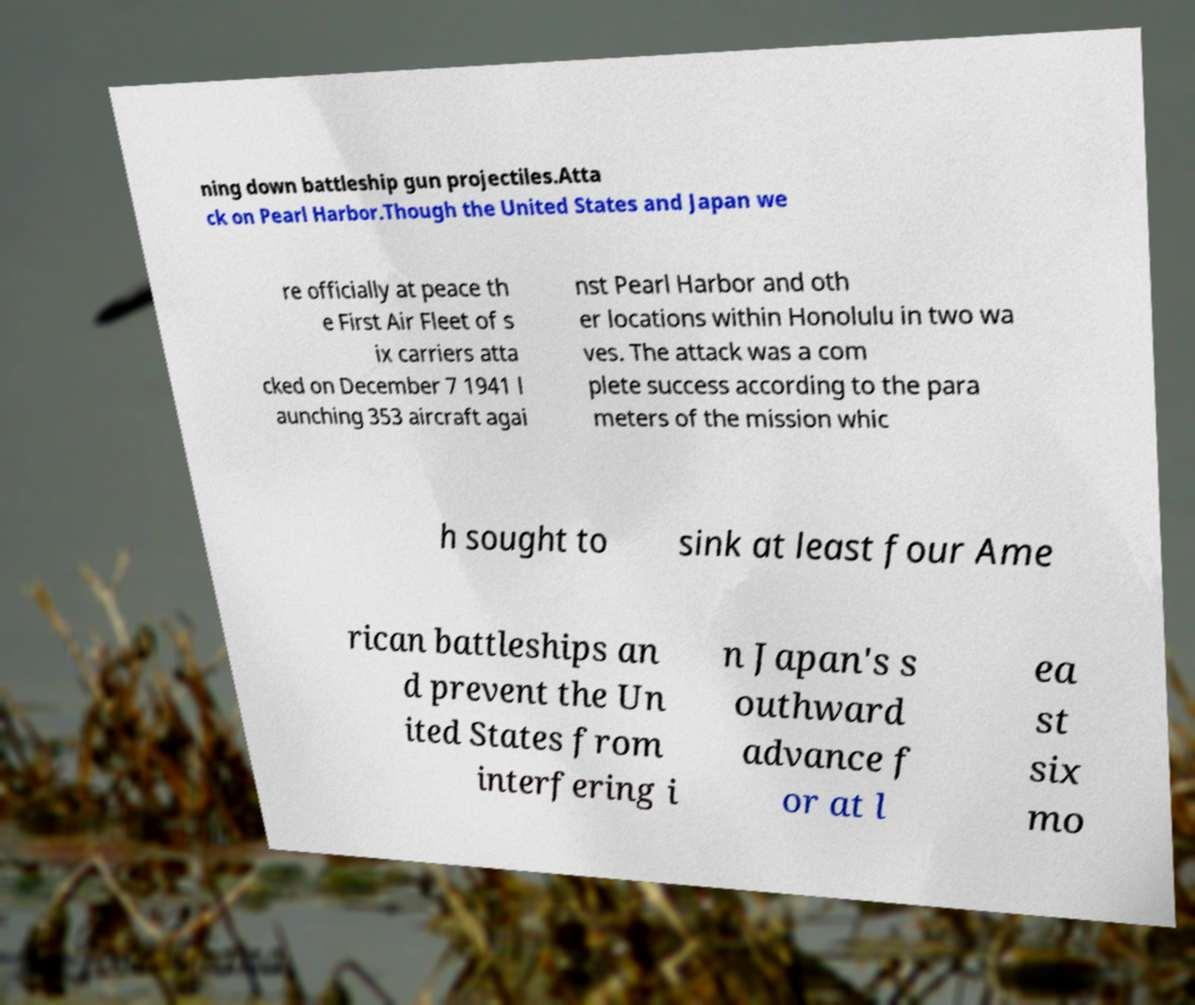Can you read and provide the text displayed in the image?This photo seems to have some interesting text. Can you extract and type it out for me? ning down battleship gun projectiles.Atta ck on Pearl Harbor.Though the United States and Japan we re officially at peace th e First Air Fleet of s ix carriers atta cked on December 7 1941 l aunching 353 aircraft agai nst Pearl Harbor and oth er locations within Honolulu in two wa ves. The attack was a com plete success according to the para meters of the mission whic h sought to sink at least four Ame rican battleships an d prevent the Un ited States from interfering i n Japan's s outhward advance f or at l ea st six mo 